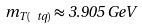Convert formula to latex. <formula><loc_0><loc_0><loc_500><loc_500>m _ { T ( \ t q ) } \approx 3 . 9 0 5 \, G e V \,</formula> 